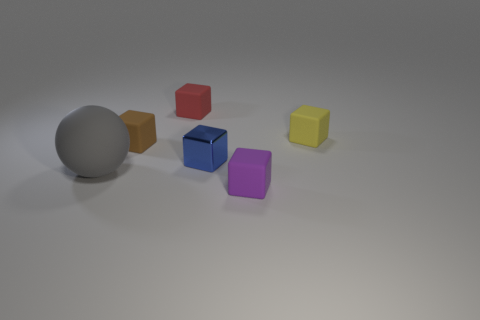Subtract all tiny blue blocks. How many blocks are left? 4 Add 1 tiny blue metallic cubes. How many objects exist? 7 Subtract all brown blocks. How many blocks are left? 4 Subtract all blocks. How many objects are left? 1 Subtract 0 brown cylinders. How many objects are left? 6 Subtract 1 blocks. How many blocks are left? 4 Subtract all red cubes. Subtract all blue cylinders. How many cubes are left? 4 Subtract all brown balls. How many cyan blocks are left? 0 Subtract all brown metal cubes. Subtract all small red matte objects. How many objects are left? 5 Add 3 small brown things. How many small brown things are left? 4 